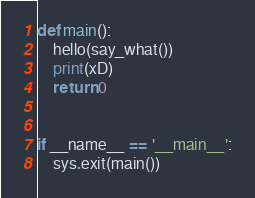Convert code to text. <code><loc_0><loc_0><loc_500><loc_500><_Python_>

def main():
    hello(say_what())
    print(xD)
    return 0


if __name__ == '__main__':
    sys.exit(main())
</code> 